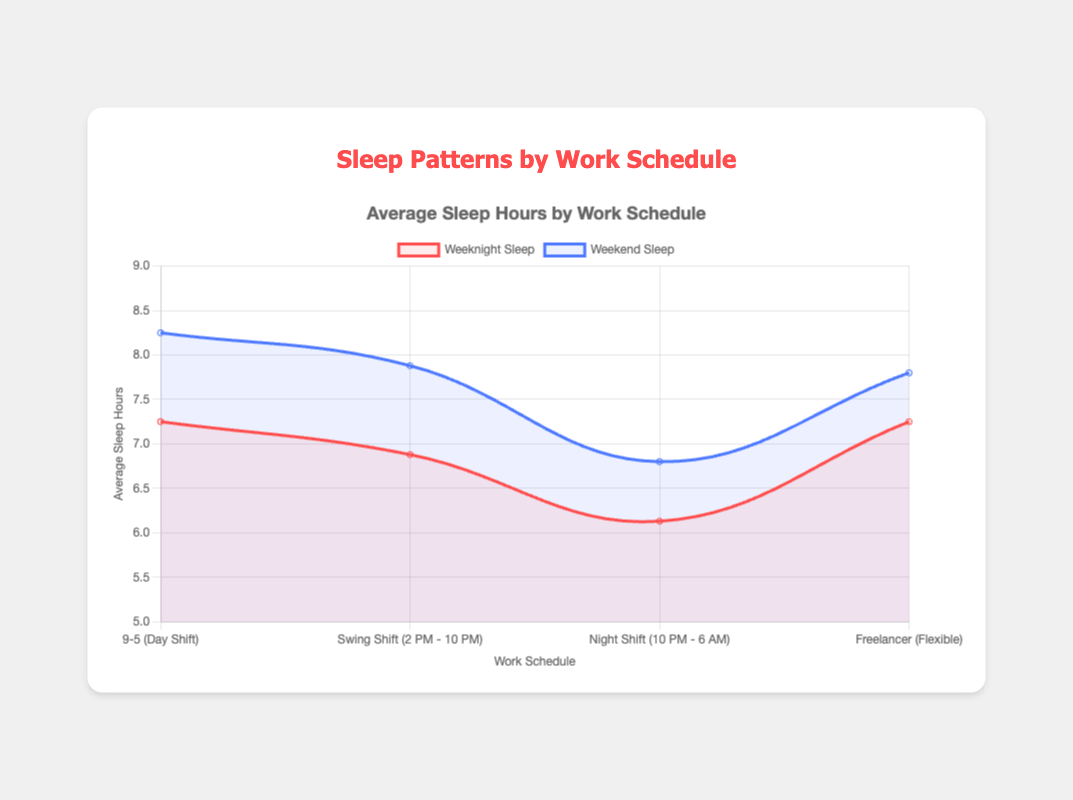Which work schedule has the highest average sleep hours on weeknights? By examining the plotted data, the "9-5 (Day Shift)" schedule has the highest average sleep hours on weeknights, with a value slightly above 7.5 hours.
Answer: 9-5 (Day Shift) How does the average weekend sleep for the "Swing Shift" compare to the "Night Shift"? By looking at the line plots, the "Swing Shift" has an average weekend sleep of slightly under 8 hours, whereas the "Night Shift" has an average of around 7 hours. This shows that the "Swing Shift" has about 1 hour more sleep on weekends compared to the "Night Shift."
Answer: Swing Shift is higher Which schedule shows the greatest difference between average weeknight and weekend sleep hours? To determine this, identify the vertical gap between weeknight and weekend sleep lines for each schedule on the plot. The "9-5 (Day Shift)" has the largest difference, moving from just above 7.5 hours on weeknights to around 8.5 hours on weekends, a difference of approximately 1 hour.
Answer: 9-5 (Day Shift) What is the average sleep duration for freelancers on weeknights? Looking at the data points, the freelancer schedule shows an average sleep duration of around 7.5 hours on weeknights. This value can be directly read from the plotted line.
Answer: 7.5 hours Between the "9-5 (Day Shift)" and the "Night Shift", which has less average sleep on weeknights, and by how much? The plot indicates that the "Night Shift" has an average sleep of around 6.2 hours, while the "9-5 (Day Shift)" is above 7.5 hours. The difference is therefore approximately 7.5 - 6.2 = 1.3 hours.
Answer: Night Shift by 1.3 hours What is the relative increase in sleep hours from weeknights to weekends for freelancers? For freelancers, the average sleep hours increase from about 7.5 on weeknights to around 7.8 on weekends. This is an increase of 7.8 - 7.5 = 0.3 hours. The relative increase can be expressed as (0.3 / 7.5) * 100, which is about 4%.
Answer: 4% Which work schedule has the lowest average sleep duration on weekends? On weekends, the "Night Shift" schedule has the lowest average sleep hours, which is slightly above 6.5 hours according to the plot.
Answer: Night Shift How do the average weeknight sleep hours of the "Swing Shift" compare to the "Freelancer" schedule? The average weeknight sleep for "Swing Shift" is slightly below 7 hours, whereas for "Freelancer," it is around 7.5 hours. Therefore, freelancers sleep more on average during weeknights compared to those on the "Swing Shift" by about 0.5 hours.
Answer: Freelancer is higher by 0.5 hours What work schedule shows nearly equal average sleep durations for both weeknights and weekends, and what are those durations? The "Freelancer" schedule shows nearly equal average sleep durations, with approximately 7.5 hours on weeknights and 7.8 hours on weekends, making the difference quite minimal.
Answer: Freelancer, 7.5 hours on weeknights and 7.8 hours on weekends 